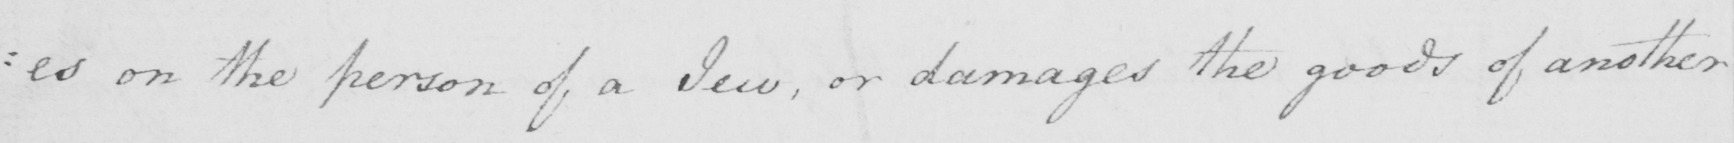What is written in this line of handwriting? : es on the person of a Jew , or damages the goods of another 